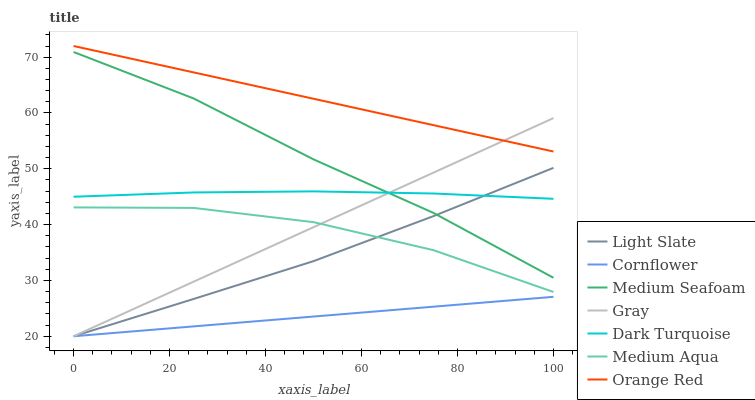Does Cornflower have the minimum area under the curve?
Answer yes or no. Yes. Does Orange Red have the maximum area under the curve?
Answer yes or no. Yes. Does Gray have the minimum area under the curve?
Answer yes or no. No. Does Gray have the maximum area under the curve?
Answer yes or no. No. Is Cornflower the smoothest?
Answer yes or no. Yes. Is Medium Aqua the roughest?
Answer yes or no. Yes. Is Gray the smoothest?
Answer yes or no. No. Is Gray the roughest?
Answer yes or no. No. Does Cornflower have the lowest value?
Answer yes or no. Yes. Does Dark Turquoise have the lowest value?
Answer yes or no. No. Does Orange Red have the highest value?
Answer yes or no. Yes. Does Gray have the highest value?
Answer yes or no. No. Is Medium Seafoam less than Orange Red?
Answer yes or no. Yes. Is Medium Aqua greater than Cornflower?
Answer yes or no. Yes. Does Gray intersect Cornflower?
Answer yes or no. Yes. Is Gray less than Cornflower?
Answer yes or no. No. Is Gray greater than Cornflower?
Answer yes or no. No. Does Medium Seafoam intersect Orange Red?
Answer yes or no. No. 